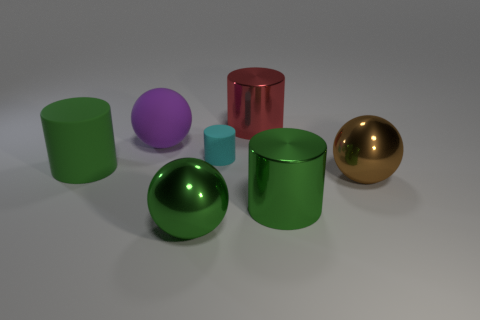How many big purple things are made of the same material as the large red cylinder?
Offer a terse response. 0. Are there the same number of big shiny objects left of the tiny cyan cylinder and big green matte cylinders that are behind the big matte sphere?
Keep it short and to the point. No. There is a large green rubber object; is it the same shape as the metal thing behind the brown thing?
Keep it short and to the point. Yes. What is the material of the other cylinder that is the same color as the big matte cylinder?
Make the answer very short. Metal. Are there any other things that have the same shape as the brown metallic thing?
Provide a succinct answer. Yes. Is the large purple sphere made of the same material as the green cylinder that is left of the large purple rubber object?
Offer a terse response. Yes. There is a metal cylinder that is in front of the sphere on the right side of the big metal cylinder that is behind the brown object; what is its color?
Offer a terse response. Green. Is there anything else that is the same size as the brown metal ball?
Make the answer very short. Yes. There is a tiny rubber cylinder; does it have the same color as the big metallic sphere that is to the left of the cyan rubber cylinder?
Your answer should be very brief. No. The small object has what color?
Provide a short and direct response. Cyan. 